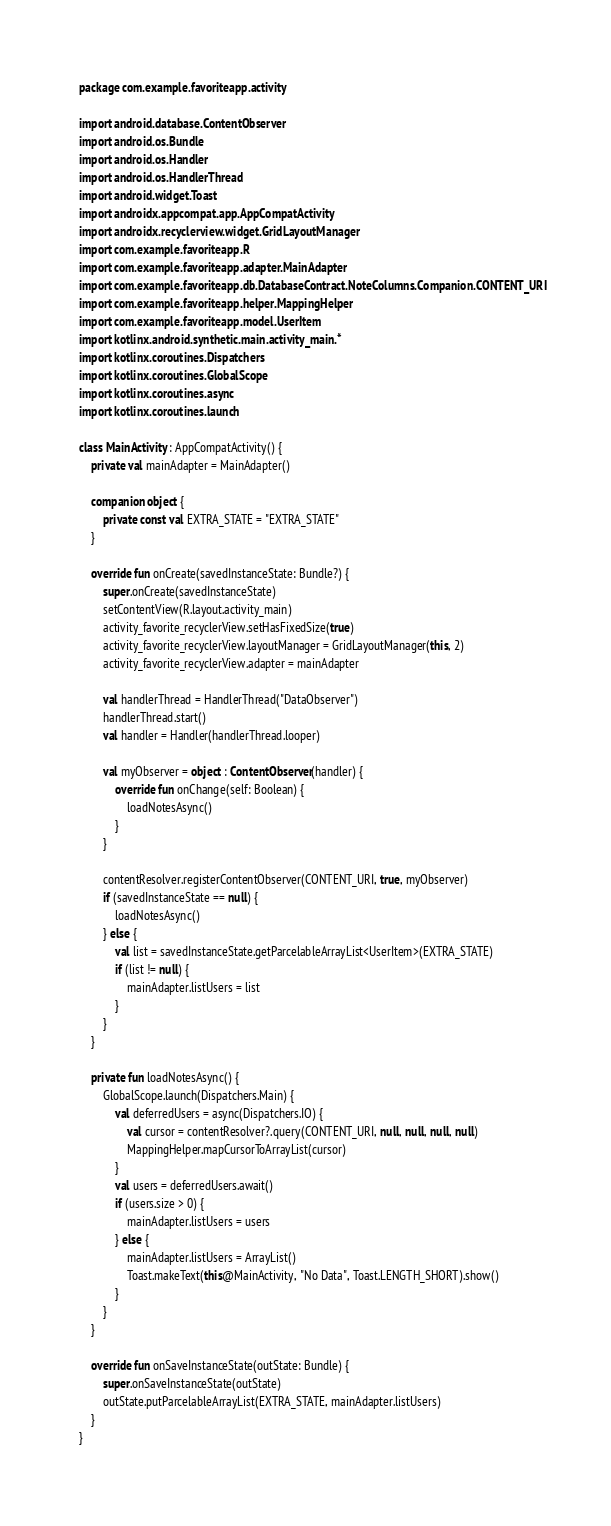Convert code to text. <code><loc_0><loc_0><loc_500><loc_500><_Kotlin_>package com.example.favoriteapp.activity

import android.database.ContentObserver
import android.os.Bundle
import android.os.Handler
import android.os.HandlerThread
import android.widget.Toast
import androidx.appcompat.app.AppCompatActivity
import androidx.recyclerview.widget.GridLayoutManager
import com.example.favoriteapp.R
import com.example.favoriteapp.adapter.MainAdapter
import com.example.favoriteapp.db.DatabaseContract.NoteColumns.Companion.CONTENT_URI
import com.example.favoriteapp.helper.MappingHelper
import com.example.favoriteapp.model.UserItem
import kotlinx.android.synthetic.main.activity_main.*
import kotlinx.coroutines.Dispatchers
import kotlinx.coroutines.GlobalScope
import kotlinx.coroutines.async
import kotlinx.coroutines.launch

class MainActivity : AppCompatActivity() {
    private val mainAdapter = MainAdapter()

    companion object {
        private const val EXTRA_STATE = "EXTRA_STATE"
    }

    override fun onCreate(savedInstanceState: Bundle?) {
        super.onCreate(savedInstanceState)
        setContentView(R.layout.activity_main)
        activity_favorite_recyclerView.setHasFixedSize(true)
        activity_favorite_recyclerView.layoutManager = GridLayoutManager(this, 2)
        activity_favorite_recyclerView.adapter = mainAdapter

        val handlerThread = HandlerThread("DataObserver")
        handlerThread.start()
        val handler = Handler(handlerThread.looper)

        val myObserver = object : ContentObserver(handler) {
            override fun onChange(self: Boolean) {
                loadNotesAsync()
            }
        }

        contentResolver.registerContentObserver(CONTENT_URI, true, myObserver)
        if (savedInstanceState == null) {
            loadNotesAsync()
        } else {
            val list = savedInstanceState.getParcelableArrayList<UserItem>(EXTRA_STATE)
            if (list != null) {
                mainAdapter.listUsers = list
            }
        }
    }

    private fun loadNotesAsync() {
        GlobalScope.launch(Dispatchers.Main) {
            val deferredUsers = async(Dispatchers.IO) {
                val cursor = contentResolver?.query(CONTENT_URI, null, null, null, null)
                MappingHelper.mapCursorToArrayList(cursor)
            }
            val users = deferredUsers.await()
            if (users.size > 0) {
                mainAdapter.listUsers = users
            } else {
                mainAdapter.listUsers = ArrayList()
                Toast.makeText(this@MainActivity, "No Data", Toast.LENGTH_SHORT).show()
            }
        }
    }

    override fun onSaveInstanceState(outState: Bundle) {
        super.onSaveInstanceState(outState)
        outState.putParcelableArrayList(EXTRA_STATE, mainAdapter.listUsers)
    }
}
</code> 